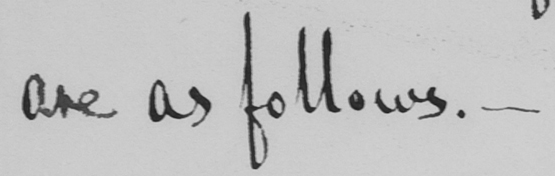Can you tell me what this handwritten text says? are as follows . _ 